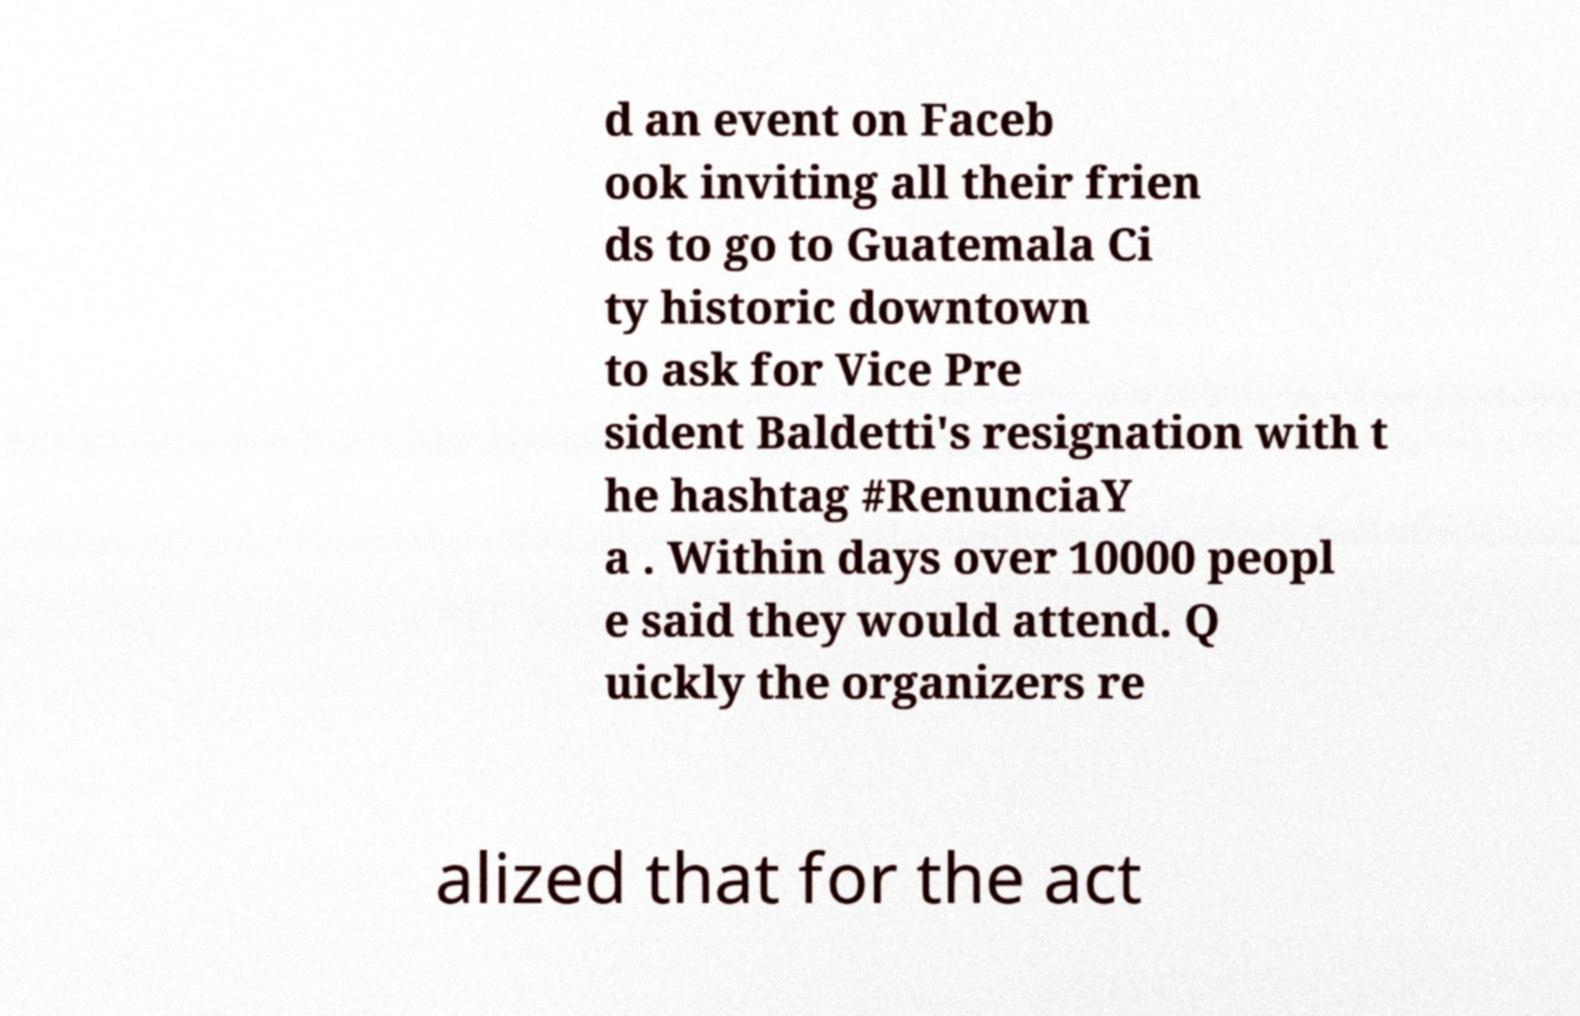Could you extract and type out the text from this image? d an event on Faceb ook inviting all their frien ds to go to Guatemala Ci ty historic downtown to ask for Vice Pre sident Baldetti's resignation with t he hashtag #RenunciaY a . Within days over 10000 peopl e said they would attend. Q uickly the organizers re alized that for the act 